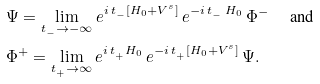<formula> <loc_0><loc_0><loc_500><loc_500>& \Psi = \lim _ { t _ { _ { - } } \to - \infty } e ^ { i \, t _ { _ { - } } [ H _ { 0 } + V ^ { s } ] } \, e ^ { - i \, t _ { _ { - } } \, H _ { 0 } } \, \Phi ^ { - } \quad \text { and} \\ & \Phi ^ { + } = \lim _ { t _ { _ { + } } \to \infty } e ^ { i \, t _ { _ { + } } H _ { 0 } } \, e ^ { - i \, t _ { _ { + } } [ H _ { 0 } + V ^ { s } ] } \, \Psi .</formula> 